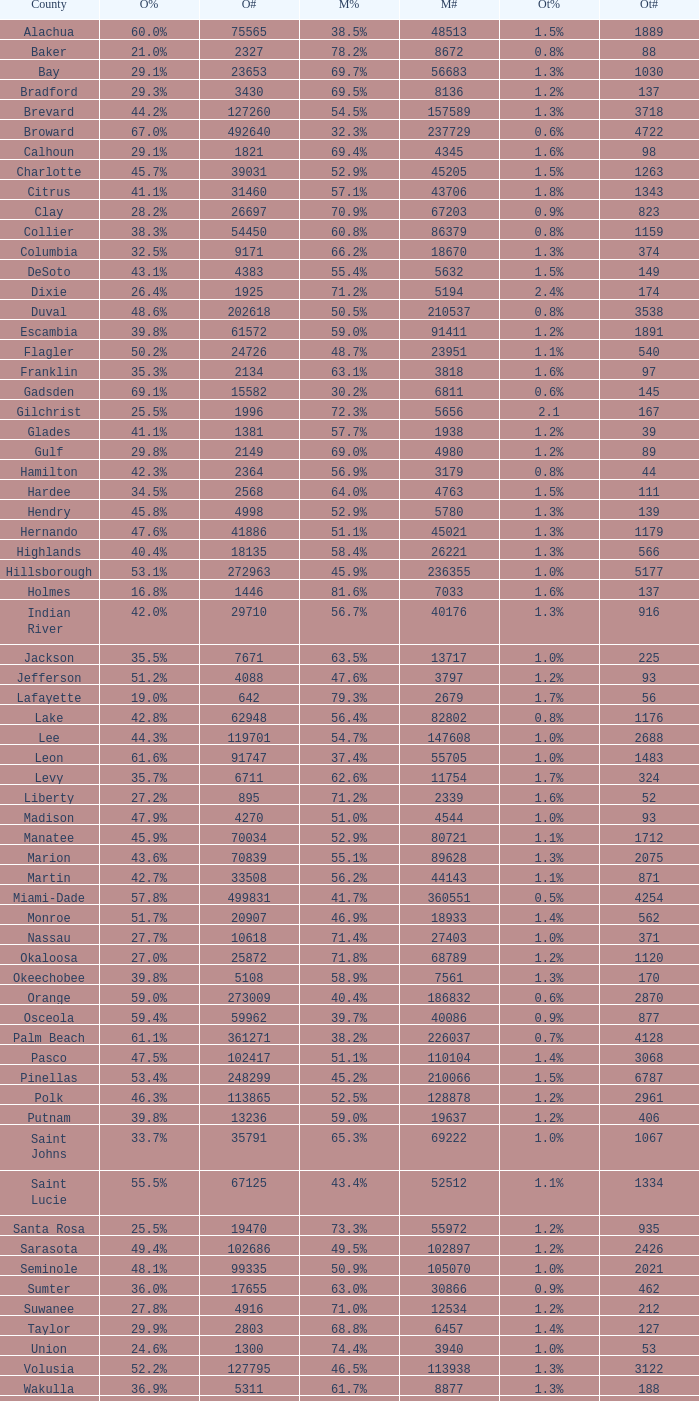What was the count of additional votes in columbia county? 374.0. 